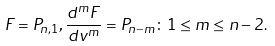Convert formula to latex. <formula><loc_0><loc_0><loc_500><loc_500>F = P _ { n , 1 } , \frac { d ^ { m } F } { d v ^ { m } } = P _ { n - m } \colon 1 \leq m \leq n - 2 .</formula> 